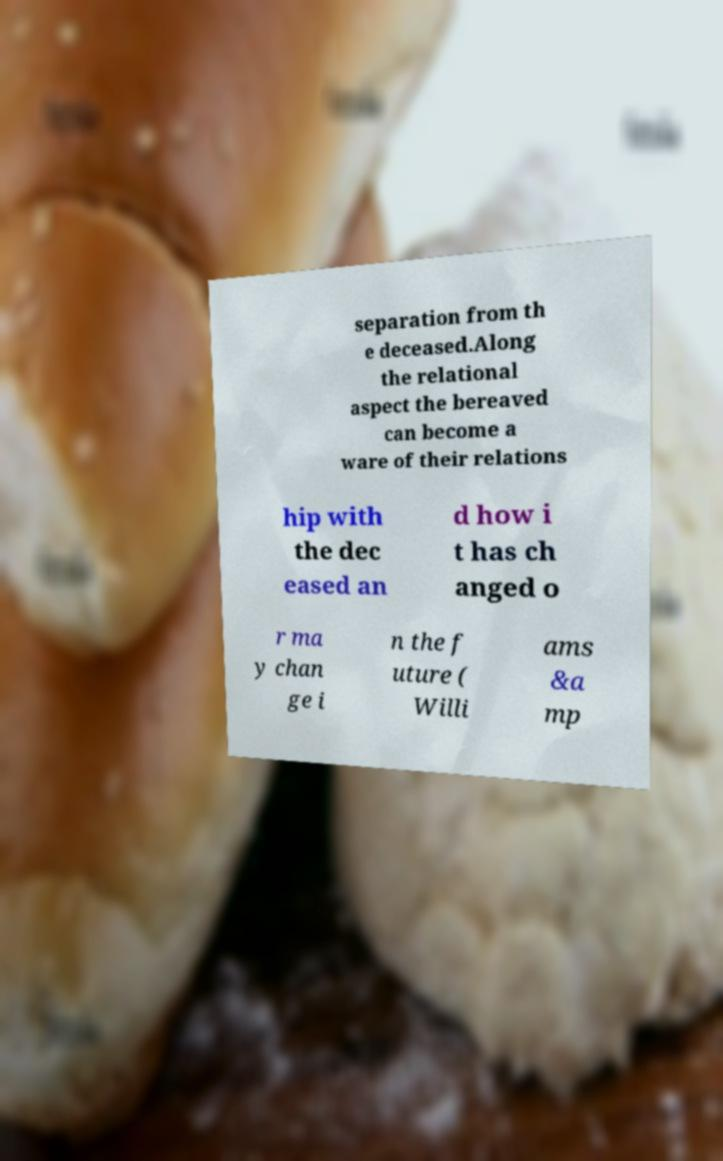Could you extract and type out the text from this image? separation from th e deceased.Along the relational aspect the bereaved can become a ware of their relations hip with the dec eased an d how i t has ch anged o r ma y chan ge i n the f uture ( Willi ams &a mp 